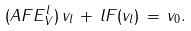Convert formula to latex. <formula><loc_0><loc_0><loc_500><loc_500>( A F E _ { V } ^ { l } ) \, v _ { l } \, + \, l F ( v _ { l } ) \, = \, v _ { 0 } .</formula> 